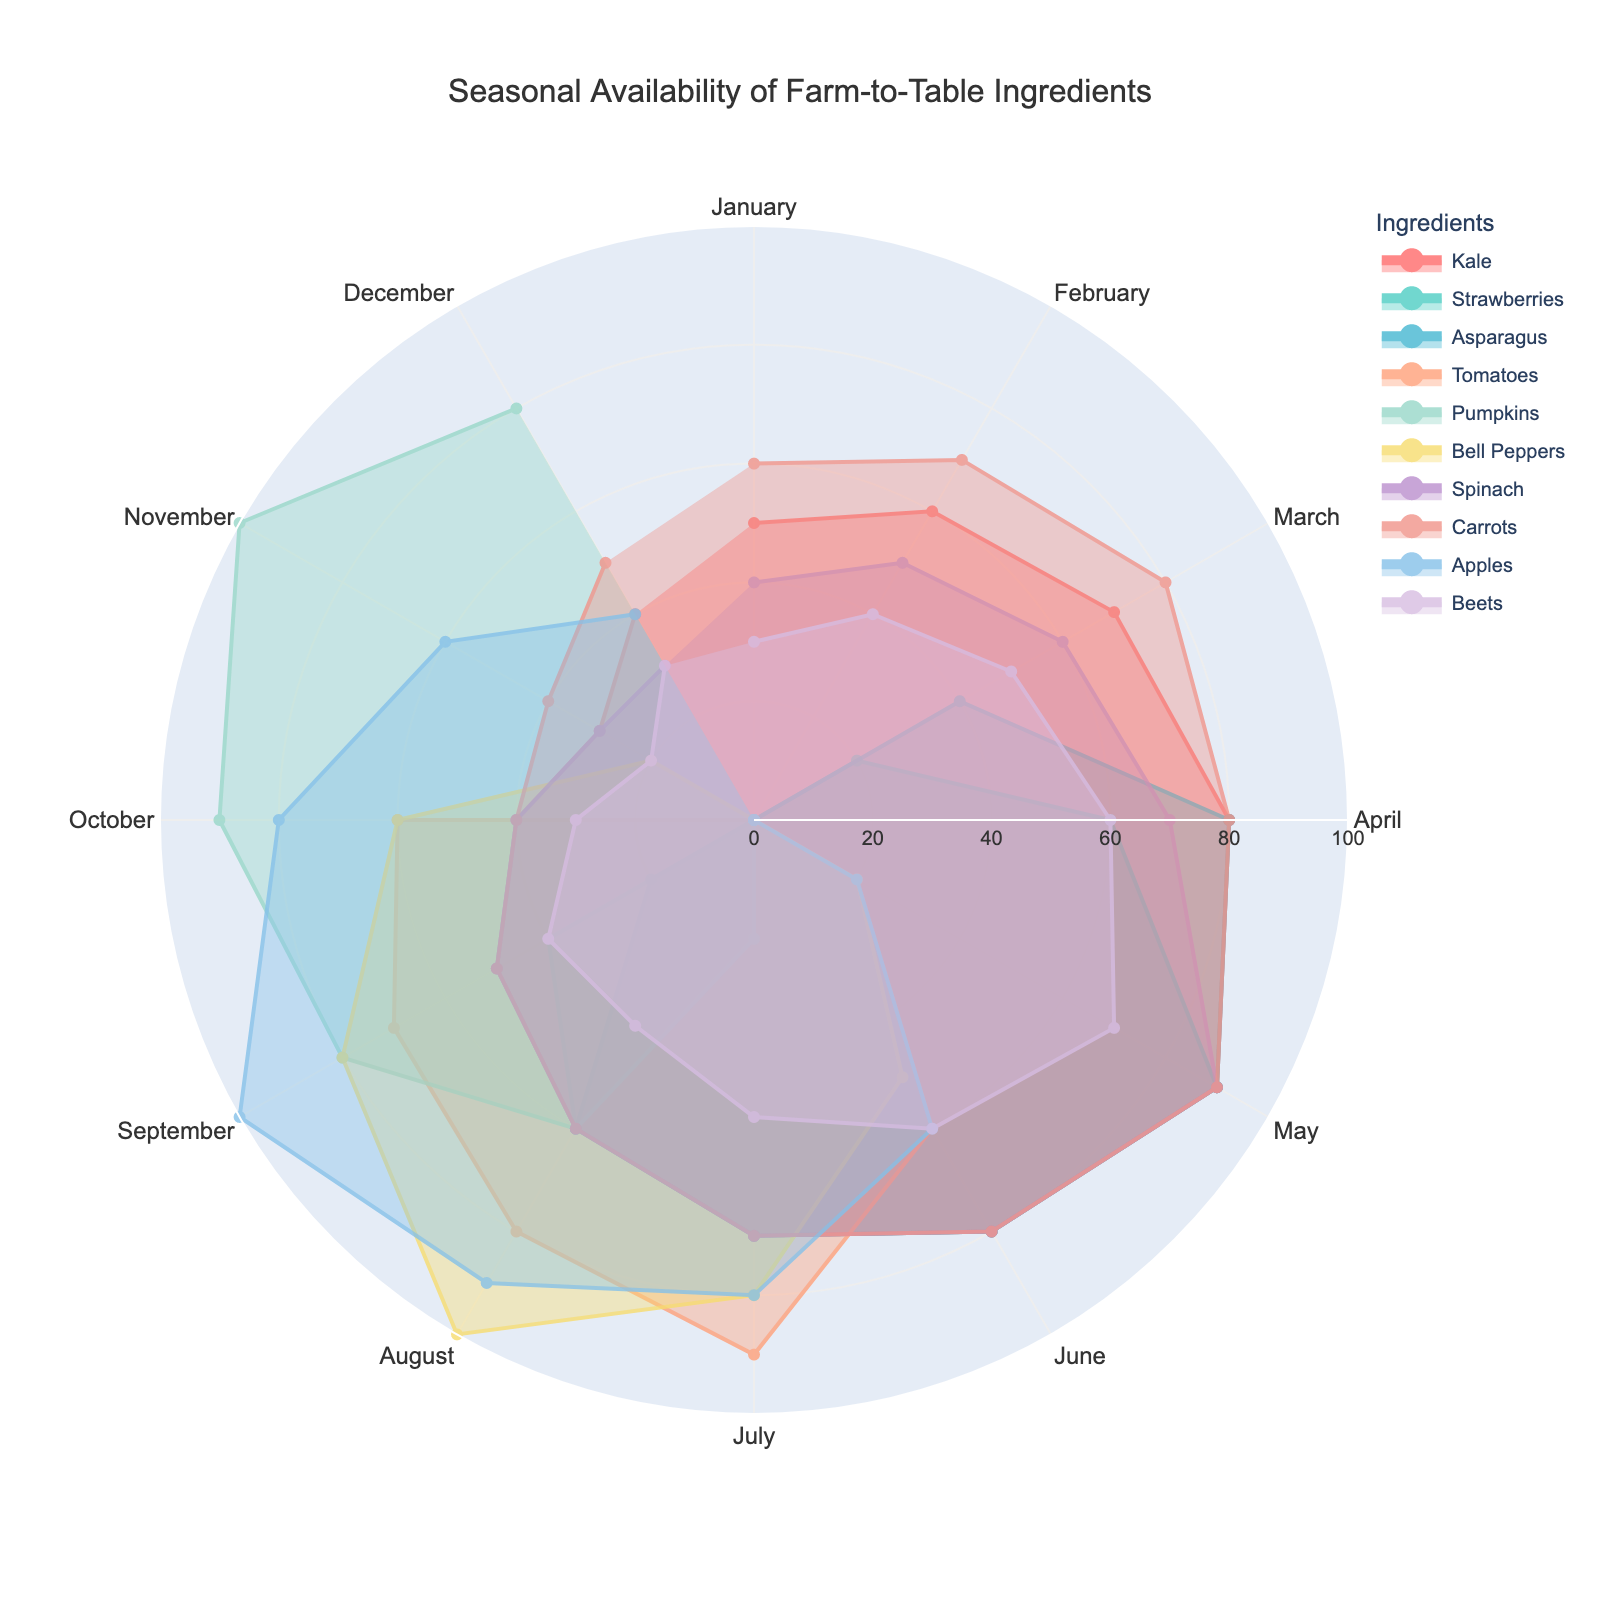Which ingredient is available the least in January? From the polar area chart, check the values for each ingredient in January. The ingredient with the smallest value is Strawberries, Asparagus, Tomatoes, and Pumpkins as they all have a value of 0.
Answer: Strawberries, Asparagus, Tomatoes, and Pumpkins Which ingredient has the peak availability in August? Identify the values of each ingredient in August. The ingredient with the highest value is Bell Peppers, with a value of 100.
Answer: Bell Peppers How does the availability of Kale change from March to July? Observe the values for Kale from March to July: 70, 80, 90, 80, and 70. Kale's availability increases from March to May, peaks in May, and then decreases in June and July.
Answer: Increases, peaks, then decreases What's the average availability of Spinach throughout the year? Sum all the monthly values for Spinach and divide by 12 (the number of months). The total is 700, so the average is 700/12 ≈ 58.33.
Answer: ≈ 58.33 During which month does Apples reach its maximum availability? Look at the monthly values of Apples and identify the maximum value, which occurs in September at 100.
Answer: September How does the availability of Tomatoes compare between July and September? Note the values for Tomatoes in July (90) and September (70). Tomatoes are more available in July than in September.
Answer: More available in July Which ingredients have zero availability in December? Check the values for each ingredient in December. The ingredients with a value of 0 are Strawberries, Asparagus, Tomatoes, and Bell Peppers.
Answer: Strawberries, Asparagus, Tomatoes, and Bell Peppers What is the total availability of Carrots over the first six months? Add the availability values of Carrots for the first six months (60+70+80+80+90+80 = 460).
Answer: 460 Which ingredient starts with zero availability and increases to peak later in the year? Look at the ingredients starting with zero before increasing. Pumpkins, Tomatoes, and Bell Peppers start with zero values before peaking later in the year.
Answer: Pumpkins, Tomatoes, and Bell Peppers Compare the availability trend of Asparagus and Beets from March to June. For Asparagus: 40, 80, 90, 80; For Beets: 50, 60, 70, 60. Asparagus increases until May then drops, while Beets increase until May then drop in June.
Answer: Asparagus increases then drops, Beets increase then drop 